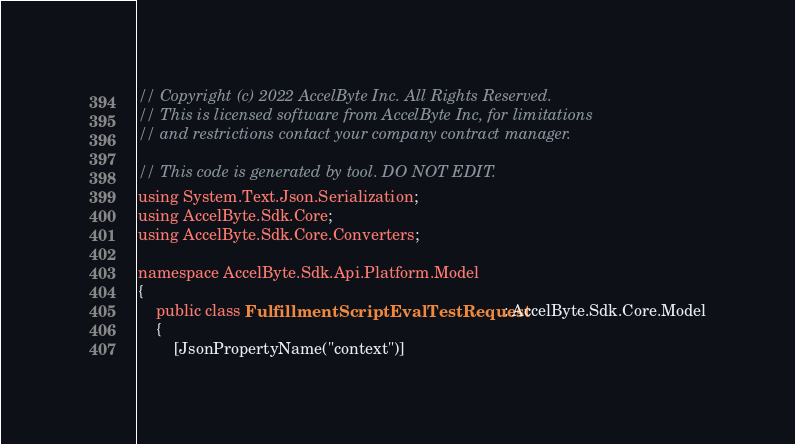Convert code to text. <code><loc_0><loc_0><loc_500><loc_500><_C#_>// Copyright (c) 2022 AccelByte Inc. All Rights Reserved.
// This is licensed software from AccelByte Inc, for limitations
// and restrictions contact your company contract manager.

// This code is generated by tool. DO NOT EDIT.
using System.Text.Json.Serialization;
using AccelByte.Sdk.Core;
using AccelByte.Sdk.Core.Converters;

namespace AccelByte.Sdk.Api.Platform.Model
{
    public class FulfillmentScriptEvalTestRequest : AccelByte.Sdk.Core.Model
    {
        [JsonPropertyName("context")]</code> 